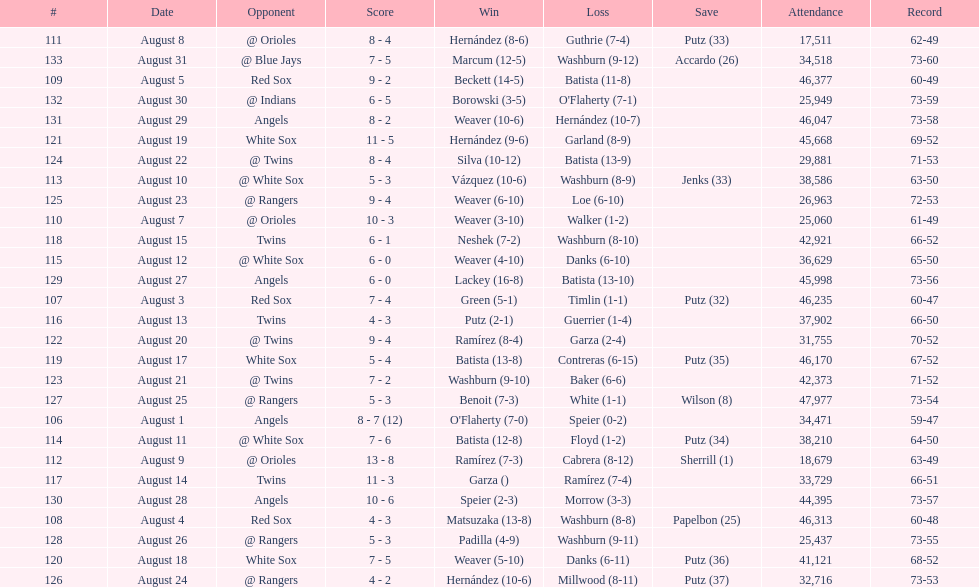How many losses during stretch? 7. 